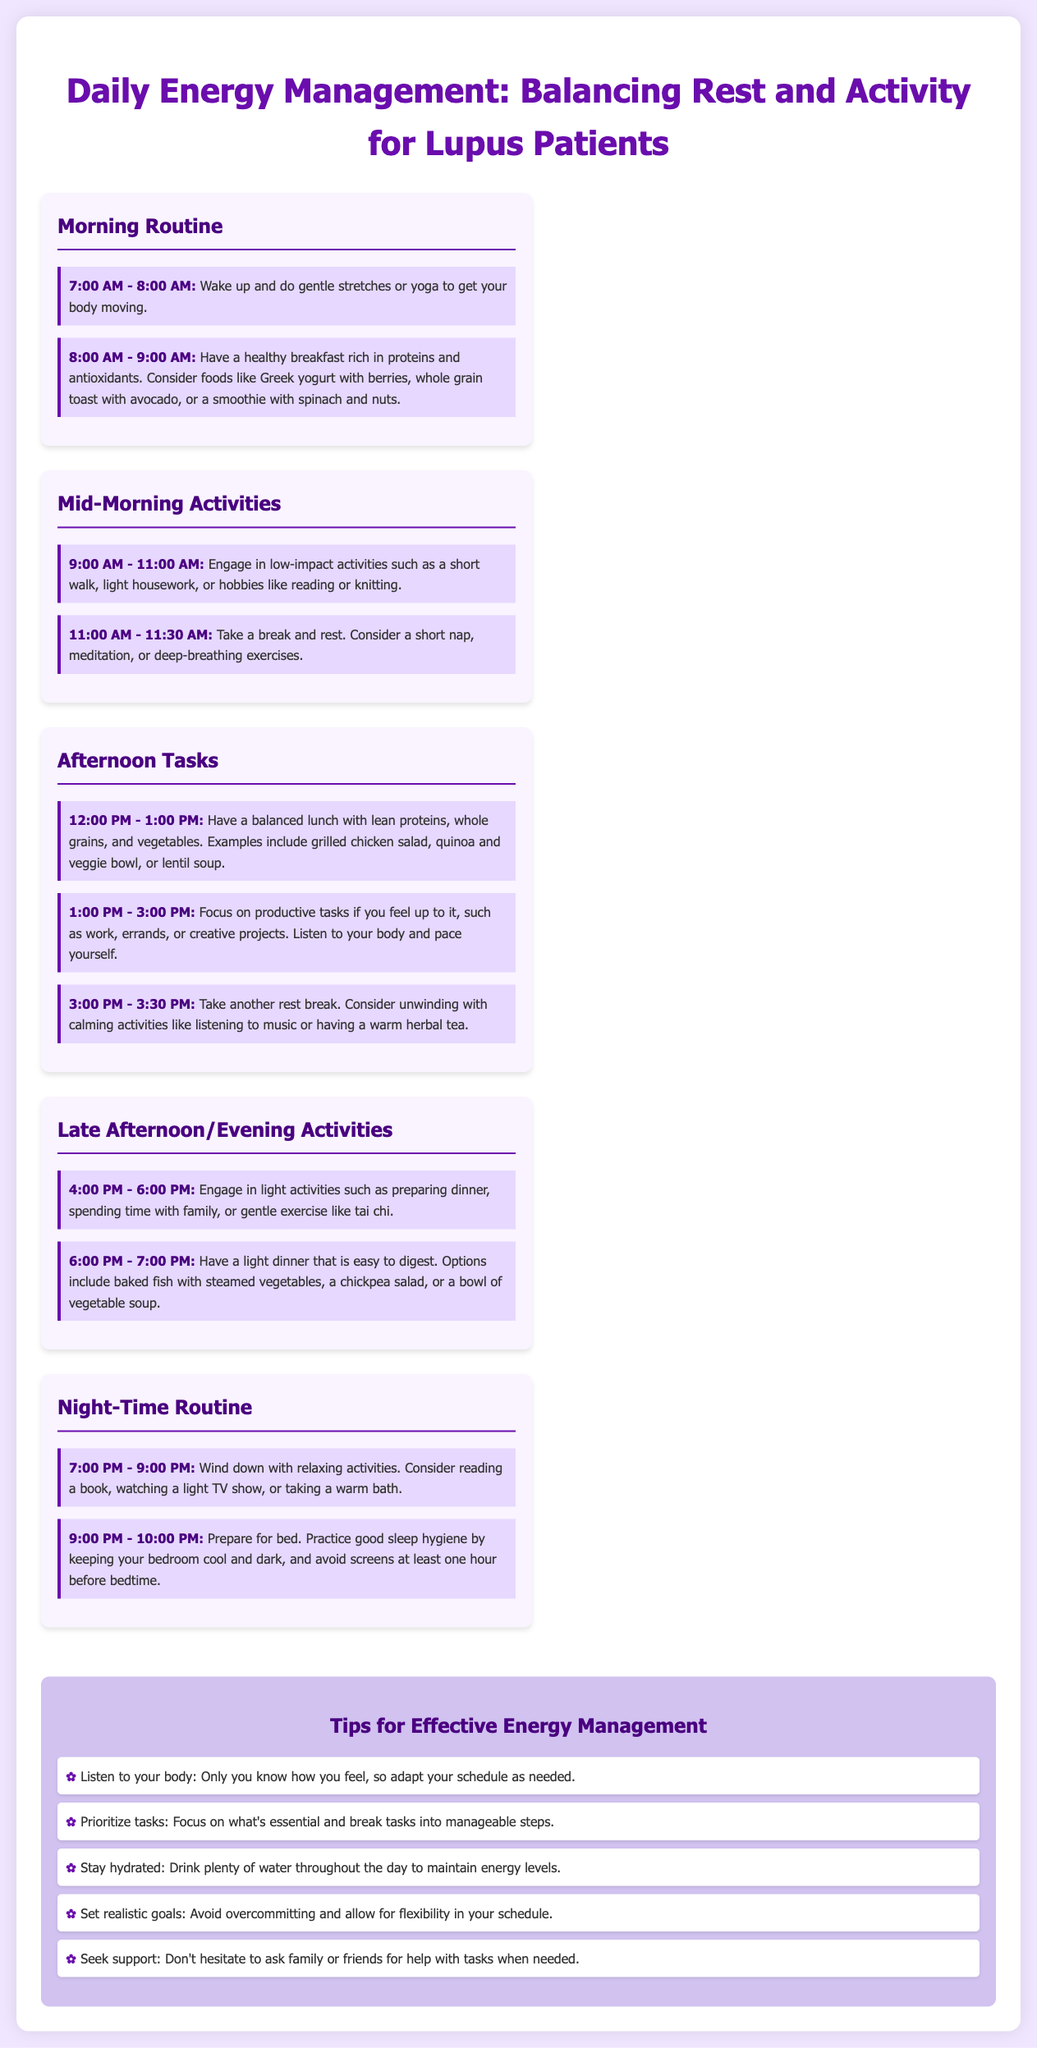What activities are suggested for the 7:00 AM - 8:00 AM time block? The document states to wake up and do gentle stretches or yoga to get your body moving.
Answer: gentle stretches or yoga What is a recommended breakfast option? The document suggests having Greek yogurt with berries, whole grain toast with avocado, or a smoothie with spinach and nuts.
Answer: Greek yogurt with berries How long is the recommended rest break after 11:00 AM? The document indicates a break of 30 minutes after 11:00 AM.
Answer: 30 minutes During which time period should lunch be consumed? The document specifies lunch should be from 12:00 PM to 1:00 PM.
Answer: 12:00 PM - 1:00 PM What time is suggested for unwinding activities? The document indicates that unwinding activities should take place from 7:00 PM to 9:00 PM.
Answer: 7:00 PM - 9:00 PM What are two light dinner options mentioned? The document lists baked fish with steamed vegetables, a chickpea salad, or a bowl of vegetable soup as options.
Answer: baked fish with steamed vegetables, chickpea salad What key tip emphasizes the importance of self-awareness? The document encourages listeners to adapt their schedule as needed based on how they feel.
Answer: Listen to your body What is the total duration suggested for productive tasks? The document suggests a duration of two hours for productive tasks from 1:00 PM to 3:00 PM.
Answer: 2 hours How is the document visually structured? The document is structured with a timeline segmented by daily routines and periods, including sections for morning, afternoon, and evening activities.
Answer: timeline segmented by daily routines 